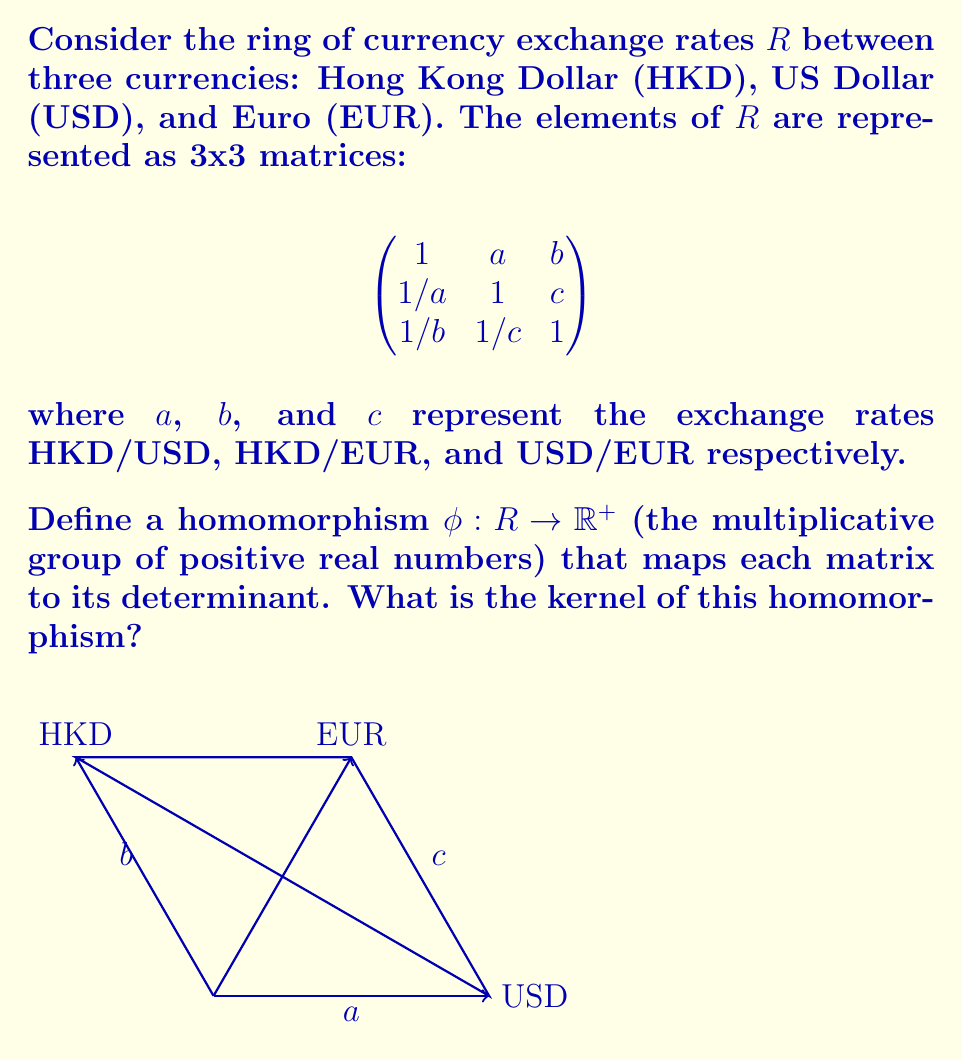Solve this math problem. Let's approach this step-by-step:

1) First, we need to calculate the determinant of the general matrix in $R$:

   $$\det\begin{pmatrix}
   1 & a & b \\
   1/a & 1 & c \\
   1/b & 1/c & 1
   \end{pmatrix} = 1 + 1 + 1 - (a/b + b/a + c/c) = 3 - (a/b + b/a + 1)$$

2) The homomorphism $\phi$ maps each matrix to this determinant value.

3) The kernel of a homomorphism is the set of all elements that map to the identity element of the codomain. In $\mathbb{R}^+$, the identity element is 1.

4) So, we need to find all matrices in $R$ where:

   $$3 - (a/b + b/a + 1) = 1$$

5) Simplifying:
   
   $$2 = a/b + b/a$$

6) This equation is satisfied when $a = b$, because:

   $$2 = a/a + a/a = 1 + 1 = 2$$

7) Therefore, the kernel of $\phi$ consists of all matrices in $R$ where $a = b$, i.e., where the HKD/USD rate equals the HKD/EUR rate.

8) In terms of the matrix representation, the kernel is:

   $$\ker(\phi) = \left\{\begin{pmatrix}
   1 & a & a \\
   1/a & 1 & c \\
   1/a & 1/c & 1
   \end{pmatrix} : a, c \in \mathbb{R}^+\right\}$$
Answer: $\ker(\phi) = \left\{\begin{pmatrix}
1 & a & a \\
1/a & 1 & c \\
1/a & 1/c & 1
\end{pmatrix} : a, c \in \mathbb{R}^+\right\}$ 